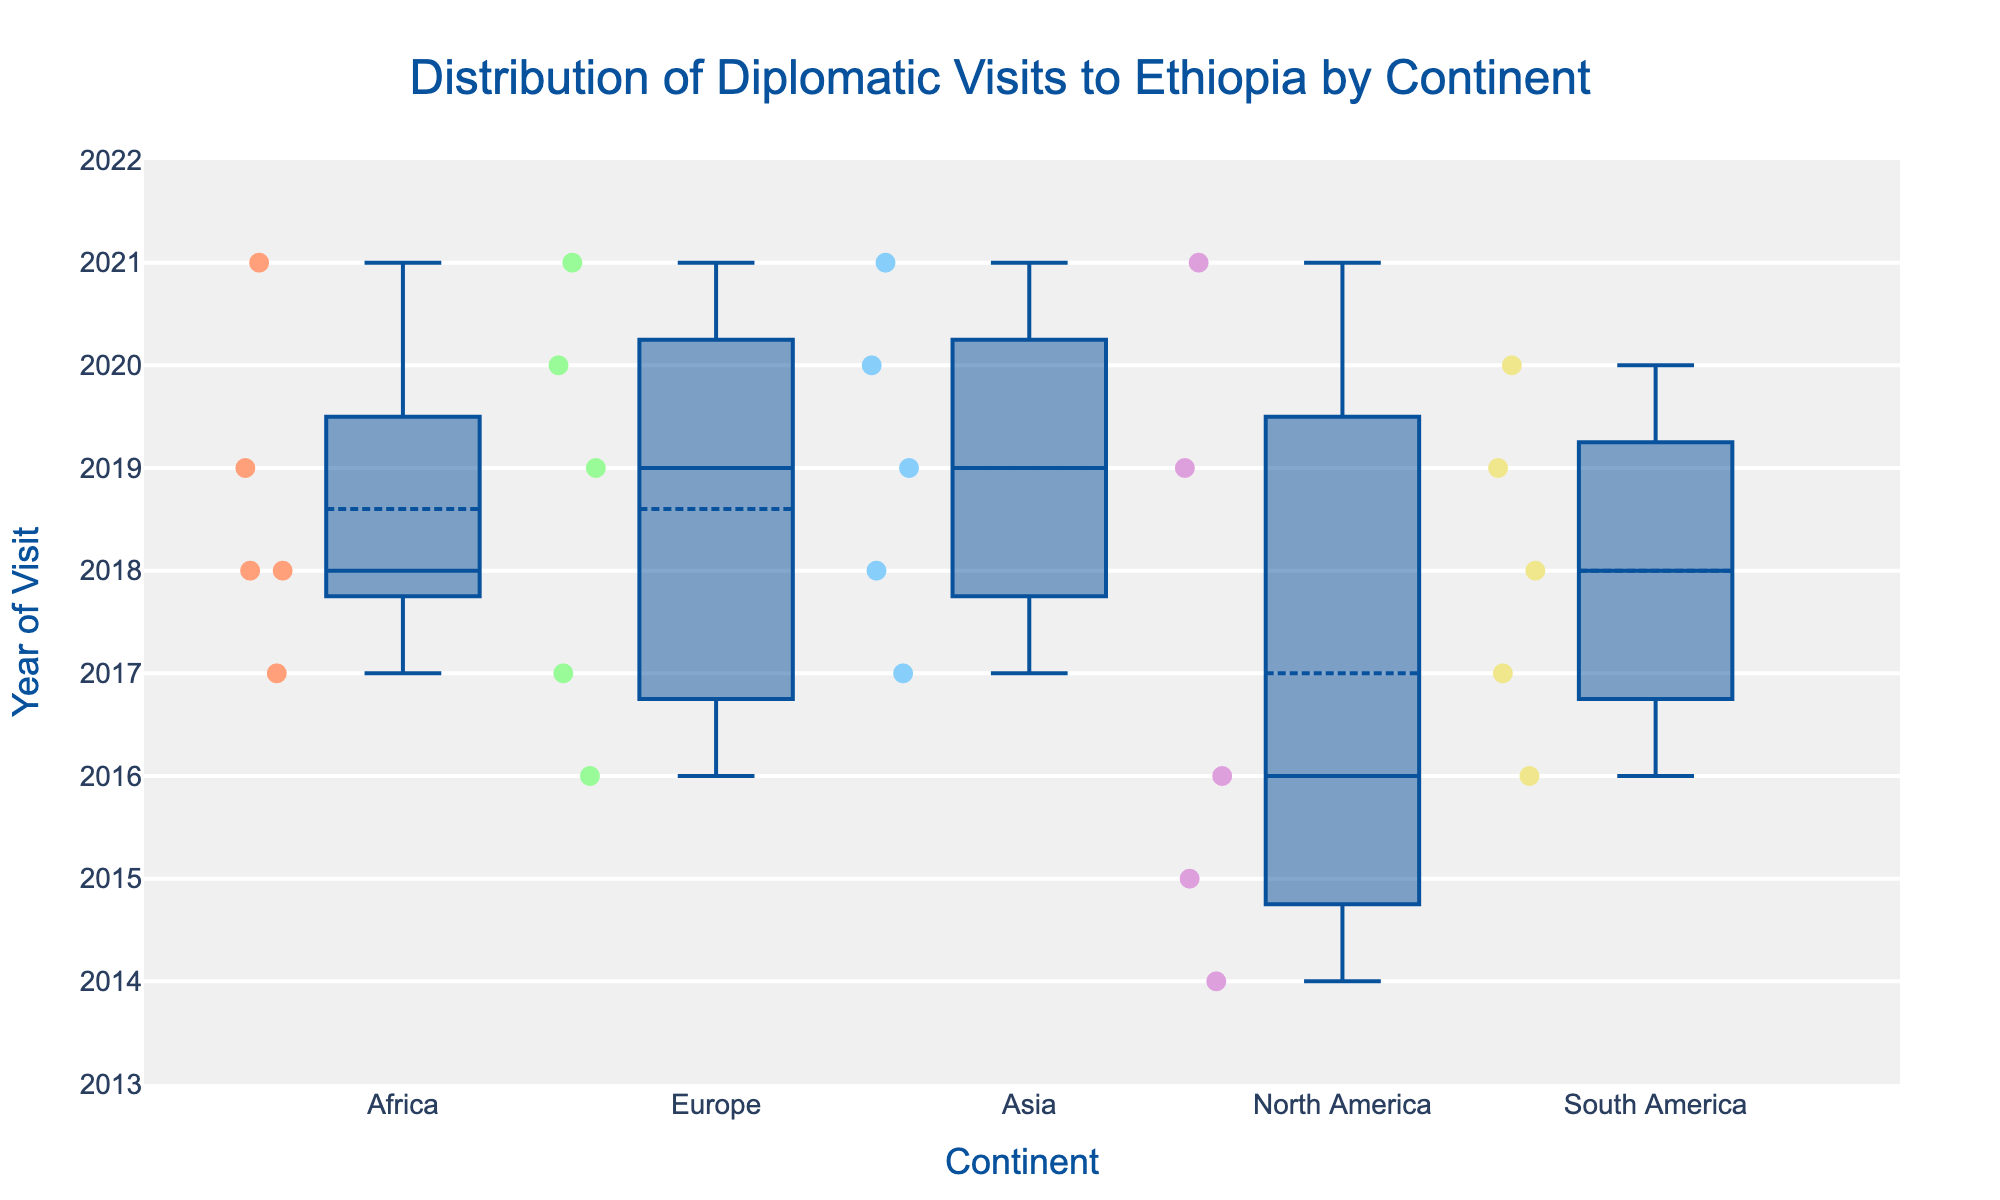What is the title of the figure? The title of the figure can be found at the top, and it reads "Distribution of Diplomatic Visits to Ethiopia by Continent".
Answer: Distribution of Diplomatic Visits to Ethiopia by Continent Which continent has the earliest recorded diplomatic visit in the dataset? To find the earliest recorded diplomatic visit, we look at the lowest points on the box plot for each continent. North America has the earliest with a visit in the year 2014.
Answer: North America How many continents are represented in the figure? The x-axis displays the different continents, and there are five distinct continents shown: Africa, Europe, Asia, North America, and South America.
Answer: Five In which year did Europe have the most frequent diplomatic visits to Ethiopia? We determine this by looking at the concentration and thickness of the scatter points within the boxes. For Europe, the highest concentration is in 2017.
Answer: 2017 Which continent had the most recent diplomatic visit to Ethiopia? We identify the most recent diplomatic visit by looking at the highest point on the box plot for each continent. South America, Asia, and North America all have visits in 2021.
Answer: South America, Asia, and North America What is the median year of diplomatic visits from Africa? On the box plot, the median is represented by the line inside the box for each continent. For Africa, the median year of visits is 2018.
Answer: 2018 How does the range of diplomatic visit years for Africa compare to Europe? The range can be noted by the distance between the minimum and maximum data points (the "whiskers" of the box plot). Europe has a range from 2016 to 2021, while Africa ranges from 2017 to 2021, making Europe's range slightly broader by one year at the lower end.
Answer: Europe has a broader range Which continent shows the greatest year-to-year variability in diplomatic visits? Year-to-year variability can be assessed by the spread of the data points within each box. Europe shows the greatest variability with visits spread out from 2016 to 2021.
Answer: Europe How many diplomatic visits does South America have between 2016 and 2020? By counting the scatter points for South America between those years on the y-axis, we find five visits: 2016, 2017, 2018, 2019, and 2020.
Answer: Five Is there any continent with no recorded diplomatic visits before 2014? By observing the box plot on the y-axis for any points below 2014, we see that all continents have visits after 2014; thus, each continent has records starting from 2014 or later.
Answer: No 